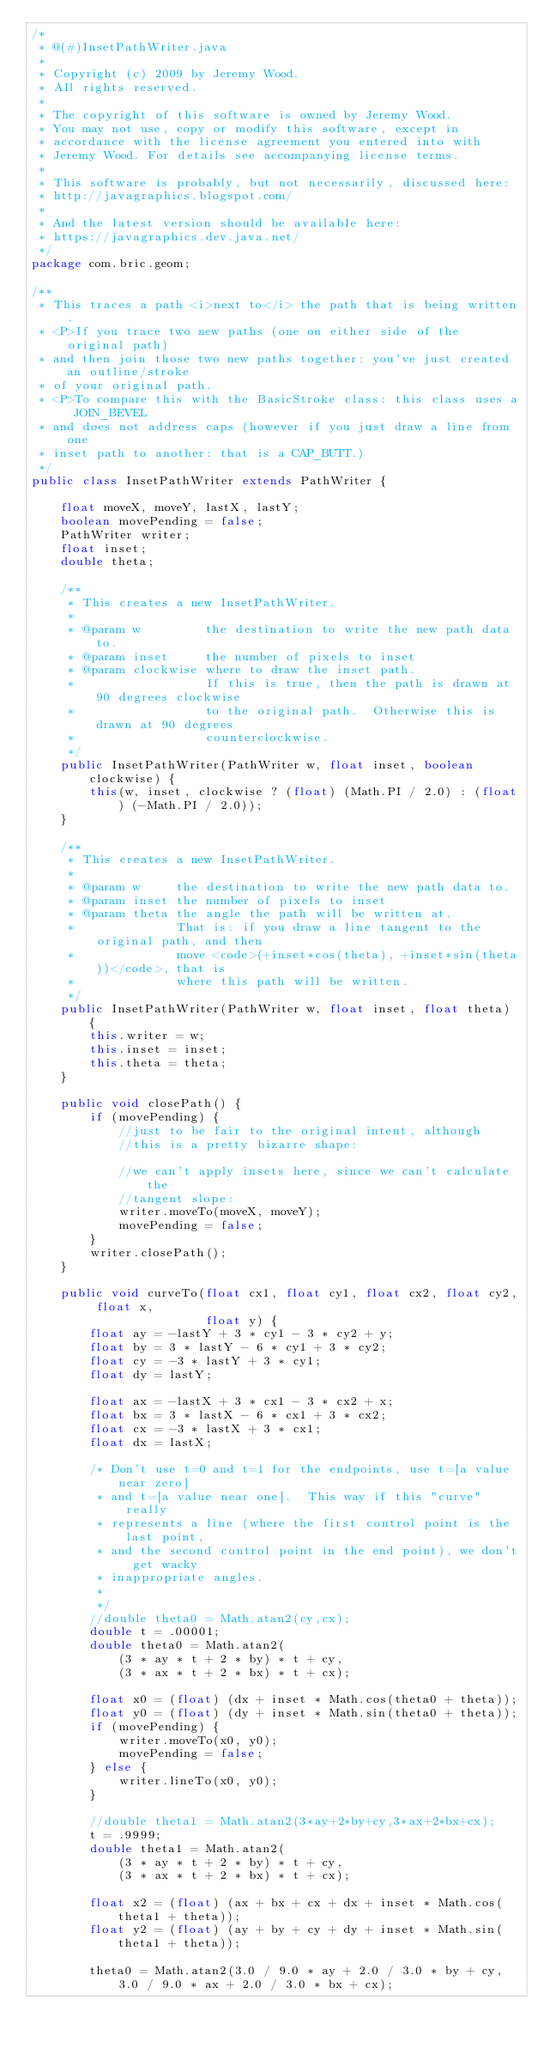Convert code to text. <code><loc_0><loc_0><loc_500><loc_500><_Java_>/*
 * @(#)InsetPathWriter.java
 *
 * Copyright (c) 2009 by Jeremy Wood.
 * All rights reserved.
 *
 * The copyright of this software is owned by Jeremy Wood. 
 * You may not use, copy or modify this software, except in  
 * accordance with the license agreement you entered into with  
 * Jeremy Wood. For details see accompanying license terms.
 * 
 * This software is probably, but not necessarily, discussed here:
 * http://javagraphics.blogspot.com/
 * 
 * And the latest version should be available here:
 * https://javagraphics.dev.java.net/
 */
package com.bric.geom;

/**
 * This traces a path <i>next to</i> the path that is being written.
 * <P>If you trace two new paths (one on either side of the original path)
 * and then join those two new paths together: you've just created an outline/stroke
 * of your original path.
 * <P>To compare this with the BasicStroke class: this class uses a JOIN_BEVEL
 * and does not address caps (however if you just draw a line from one
 * inset path to another: that is a CAP_BUTT.)
 */
public class InsetPathWriter extends PathWriter {

    float moveX, moveY, lastX, lastY;
    boolean movePending = false;
    PathWriter writer;
    float inset;
    double theta;

    /**
     * This creates a new InsetPathWriter.
     *
     * @param w         the destination to write the new path data to.
     * @param inset     the number of pixels to inset
     * @param clockwise where to draw the inset path.
     *                  If this is true, then the path is drawn at 90 degrees clockwise
     *                  to the original path.  Otherwise this is drawn at 90 degrees
     *                  counterclockwise.
     */
    public InsetPathWriter(PathWriter w, float inset, boolean clockwise) {
        this(w, inset, clockwise ? (float) (Math.PI / 2.0) : (float) (-Math.PI / 2.0));
    }

    /**
     * This creates a new InsetPathWriter.
     *
     * @param w     the destination to write the new path data to.
     * @param inset the number of pixels to inset
     * @param theta the angle the path will be written at.
     *              That is: if you draw a line tangent to the original path, and then
     *              move <code>(+inset*cos(theta), +inset*sin(theta))</code>, that is
     *              where this path will be written.
     */
    public InsetPathWriter(PathWriter w, float inset, float theta) {
        this.writer = w;
        this.inset = inset;
        this.theta = theta;
    }

    public void closePath() {
        if (movePending) {
            //just to be fair to the original intent, although
            //this is a pretty bizarre shape:

            //we can't apply insets here, since we can't calculate the
            //tangent slope:
            writer.moveTo(moveX, moveY);
            movePending = false;
        }
        writer.closePath();
    }

    public void curveTo(float cx1, float cy1, float cx2, float cy2, float x,
                        float y) {
        float ay = -lastY + 3 * cy1 - 3 * cy2 + y;
        float by = 3 * lastY - 6 * cy1 + 3 * cy2;
        float cy = -3 * lastY + 3 * cy1;
        float dy = lastY;

        float ax = -lastX + 3 * cx1 - 3 * cx2 + x;
        float bx = 3 * lastX - 6 * cx1 + 3 * cx2;
        float cx = -3 * lastX + 3 * cx1;
        float dx = lastX;

        /* Don't use t=0 and t=1 for the endpoints, use t=[a value near zero]
         * and t=[a value near one].  This way if this "curve" really 
         * represents a line (where the first control point is the last point,
         * and the second control point in the end point), we don't get wacky
         * inappropriate angles.
         * 
         */
        //double theta0 = Math.atan2(cy,cx);
        double t = .00001;
        double theta0 = Math.atan2(
            (3 * ay * t + 2 * by) * t + cy,
            (3 * ax * t + 2 * bx) * t + cx);

        float x0 = (float) (dx + inset * Math.cos(theta0 + theta));
        float y0 = (float) (dy + inset * Math.sin(theta0 + theta));
        if (movePending) {
            writer.moveTo(x0, y0);
            movePending = false;
        } else {
            writer.lineTo(x0, y0);
        }

        //double theta1 = Math.atan2(3*ay+2*by+cy,3*ax+2*bx+cx);
        t = .9999;
        double theta1 = Math.atan2(
            (3 * ay * t + 2 * by) * t + cy,
            (3 * ax * t + 2 * bx) * t + cx);

        float x2 = (float) (ax + bx + cx + dx + inset * Math.cos(theta1 + theta));
        float y2 = (float) (ay + by + cy + dy + inset * Math.sin(theta1 + theta));

        theta0 = Math.atan2(3.0 / 9.0 * ay + 2.0 / 3.0 * by + cy, 3.0 / 9.0 * ax + 2.0 / 3.0 * bx + cx);</code> 